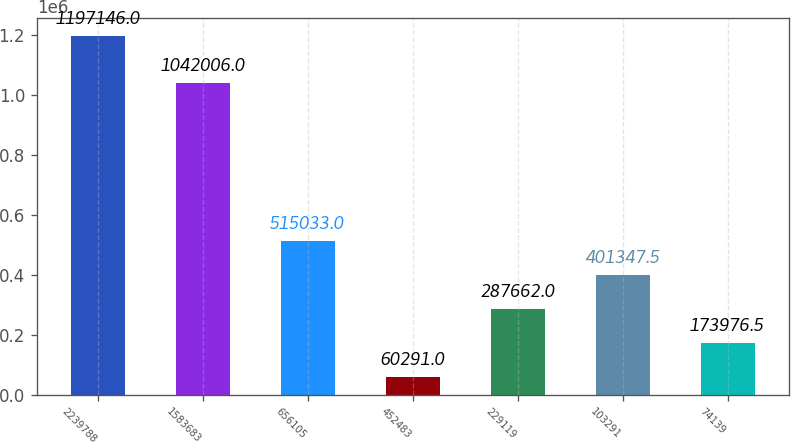<chart> <loc_0><loc_0><loc_500><loc_500><bar_chart><fcel>2239788<fcel>1583683<fcel>656105<fcel>452483<fcel>229119<fcel>103291<fcel>74139<nl><fcel>1.19715e+06<fcel>1.04201e+06<fcel>515033<fcel>60291<fcel>287662<fcel>401348<fcel>173976<nl></chart> 